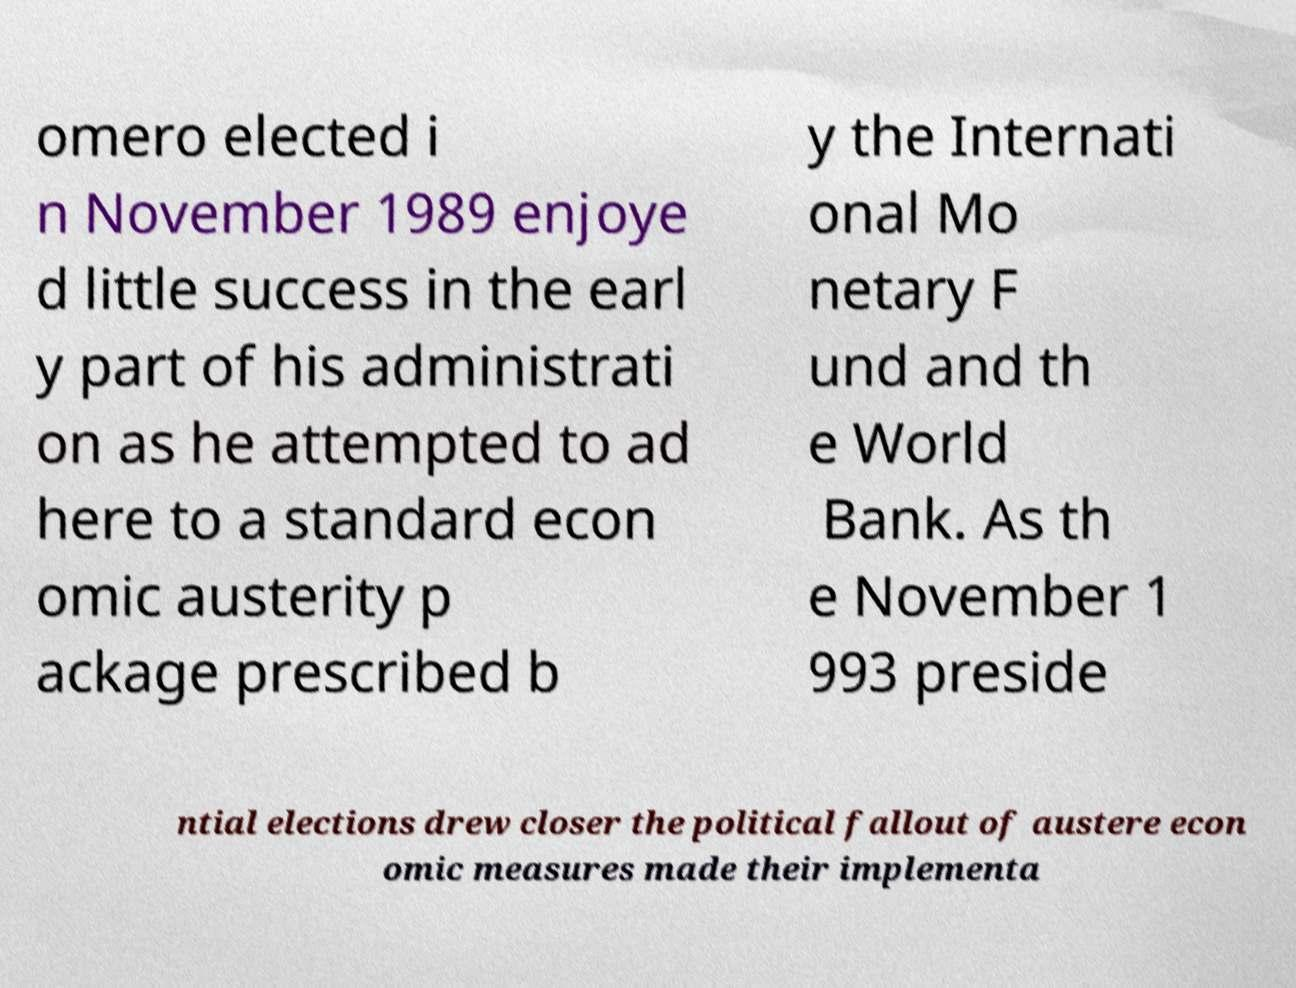Could you extract and type out the text from this image? omero elected i n November 1989 enjoye d little success in the earl y part of his administrati on as he attempted to ad here to a standard econ omic austerity p ackage prescribed b y the Internati onal Mo netary F und and th e World Bank. As th e November 1 993 preside ntial elections drew closer the political fallout of austere econ omic measures made their implementa 